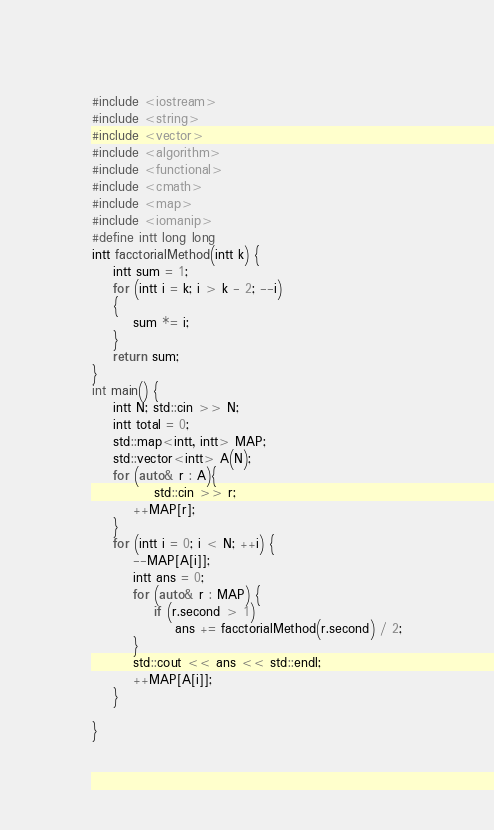Convert code to text. <code><loc_0><loc_0><loc_500><loc_500><_C++_>#include <iostream>
#include <string>
#include <vector>
#include <algorithm>
#include <functional>
#include <cmath>
#include <map>
#include <iomanip>
#define intt long long
intt facctorialMethod(intt k) {
	intt sum = 1;
	for (intt i = k; i > k - 2; --i)
	{
		sum *= i;
	}
	return sum;
}
int main() {
	intt N; std::cin >> N;
	intt total = 0;
	std::map<intt, intt> MAP;
	std::vector<intt> A(N);
	for (auto& r : A){
			std::cin >> r;
		++MAP[r];
	}
	for (intt i = 0; i < N; ++i) {
		--MAP[A[i]];
		intt ans = 0;
		for (auto& r : MAP) {
			if (r.second > 1)
				ans += facctorialMethod(r.second) / 2;
		}
		std::cout << ans << std::endl;
		++MAP[A[i]];
	}

}</code> 